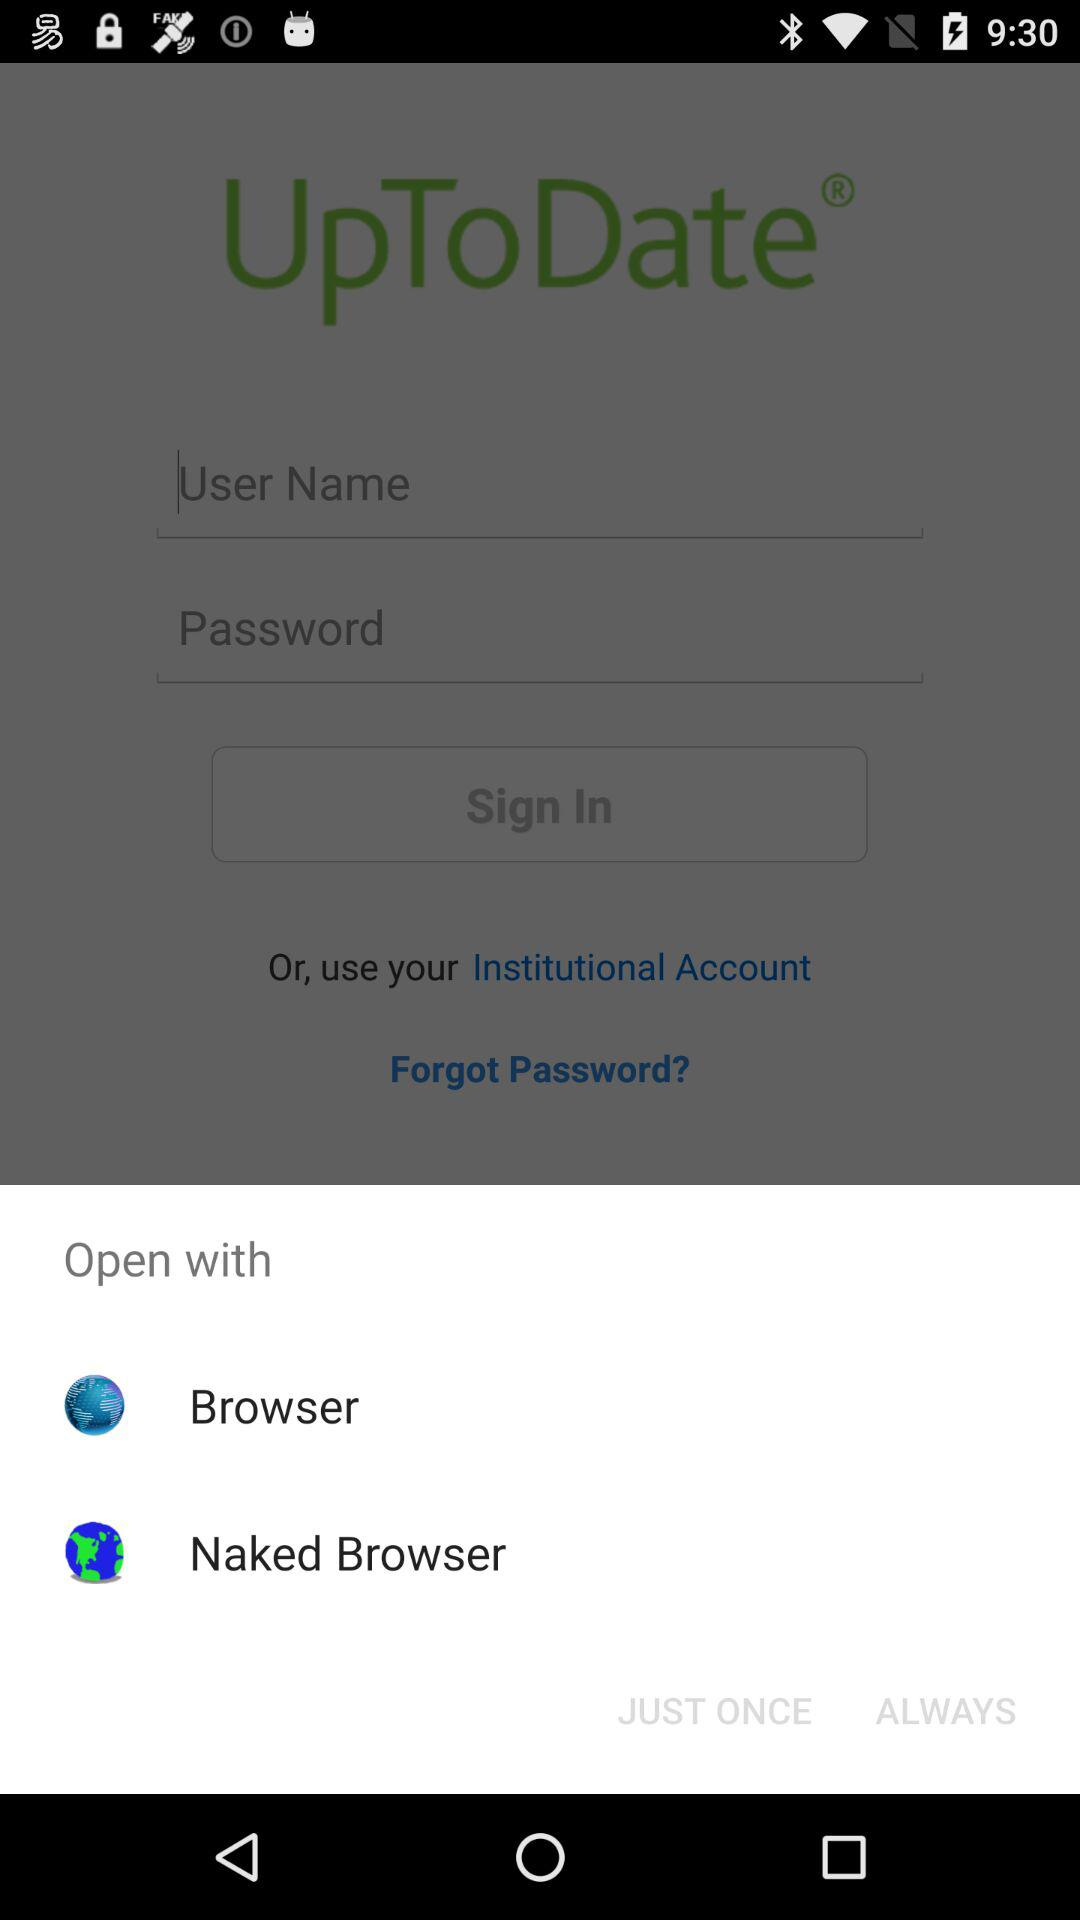What applications can be used to open? The applications are: "Browser" and "Naked Browser". 